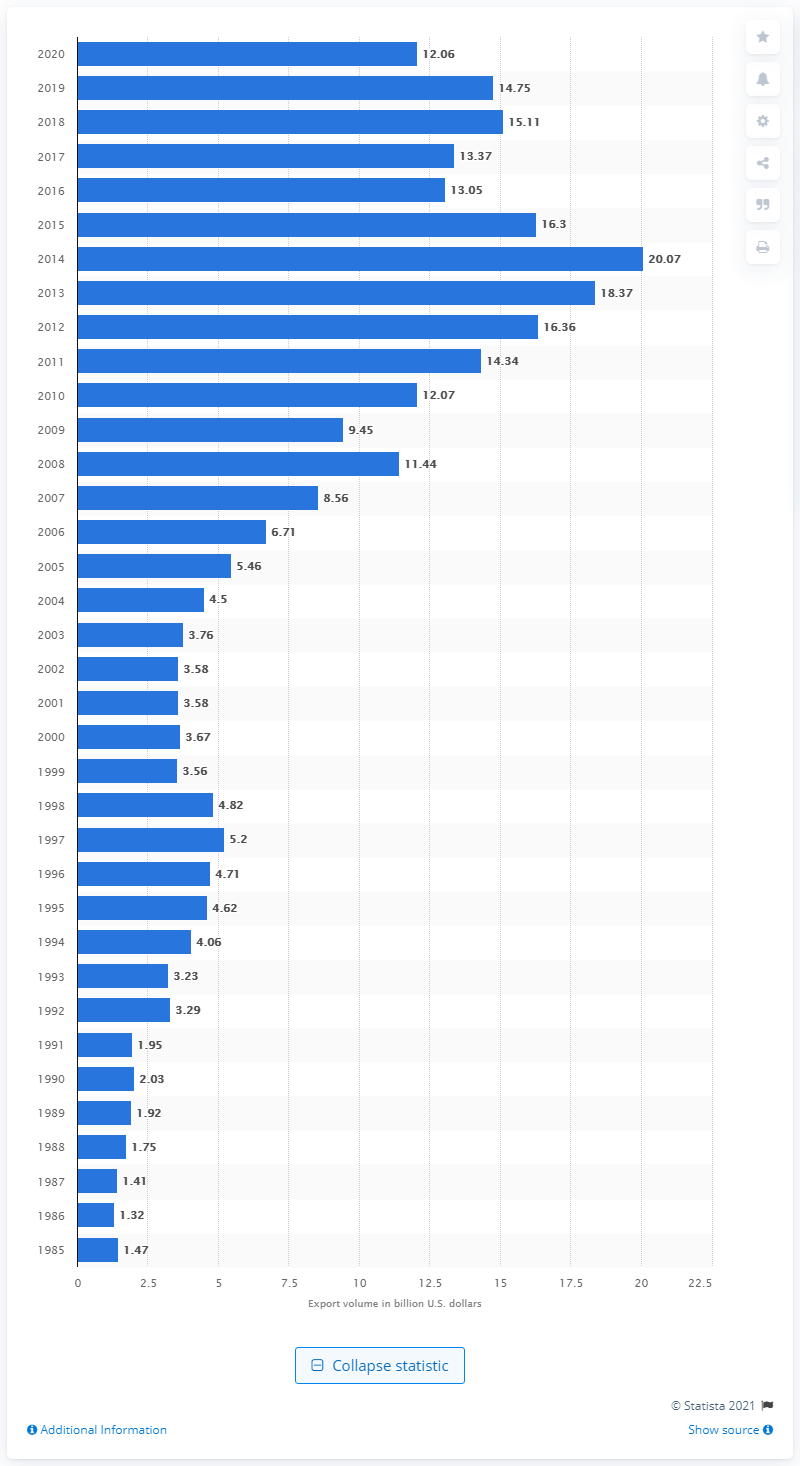Point out several critical features in this image. In 2020, the United States exported a total of $12.06 billion in goods to Colombia. 